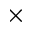Convert formula to latex. <formula><loc_0><loc_0><loc_500><loc_500>\times</formula> 